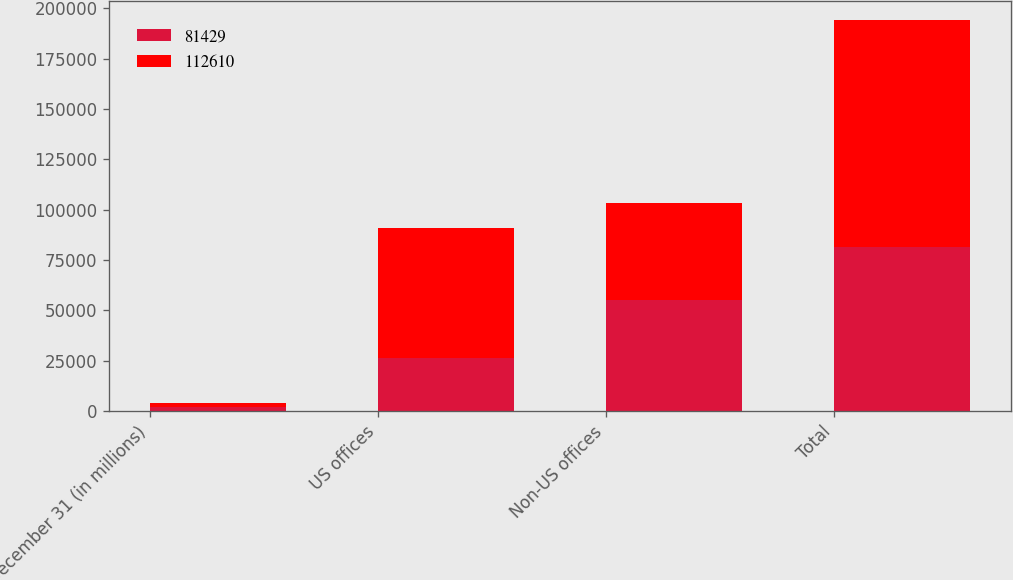<chart> <loc_0><loc_0><loc_500><loc_500><stacked_bar_chart><ecel><fcel>December 31 (in millions)<fcel>US offices<fcel>Non-US offices<fcel>Total<nl><fcel>81429<fcel>2016<fcel>26180<fcel>55249<fcel>81429<nl><fcel>112610<fcel>2015<fcel>64519<fcel>48091<fcel>112610<nl></chart> 